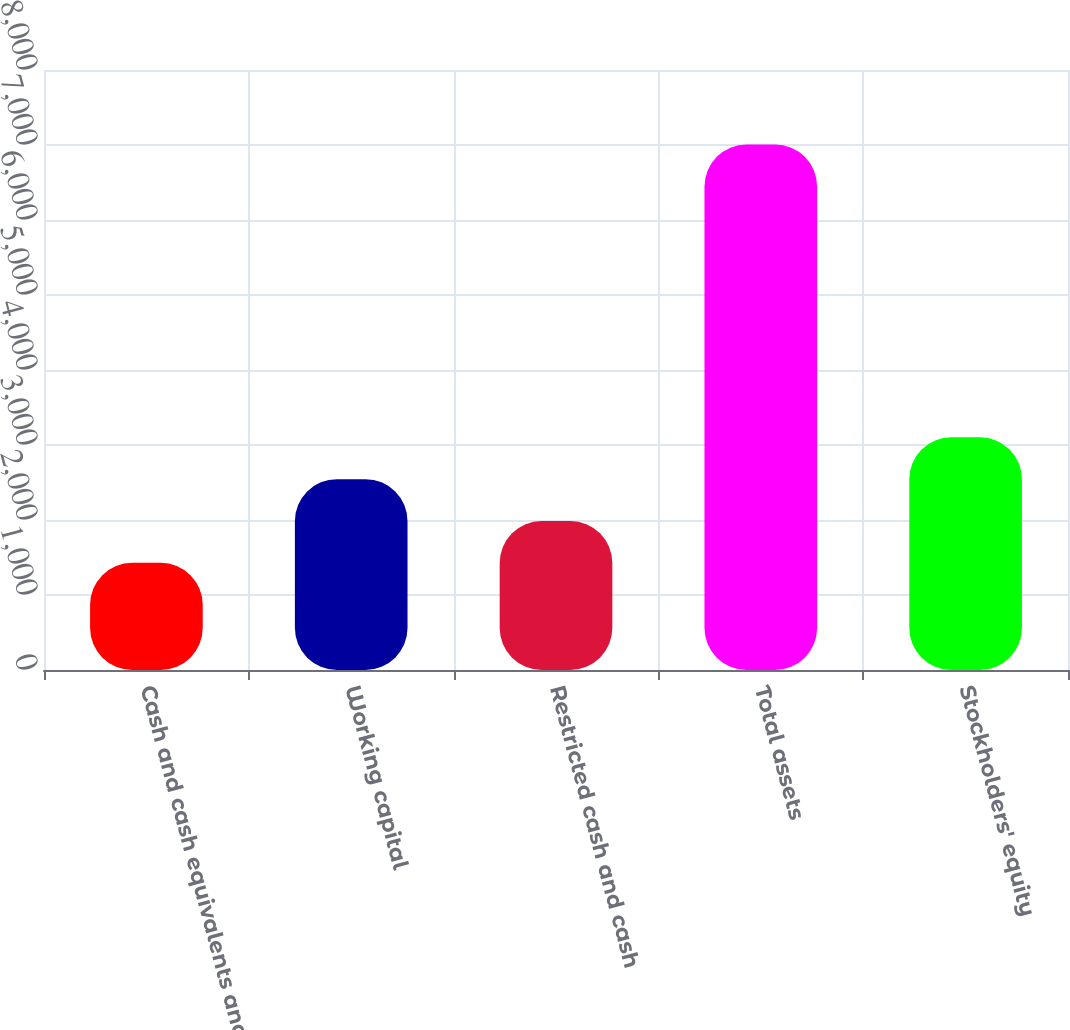Convert chart to OTSL. <chart><loc_0><loc_0><loc_500><loc_500><bar_chart><fcel>Cash and cash equivalents and<fcel>Working capital<fcel>Restricted cash and cash<fcel>Total assets<fcel>Stockholders' equity<nl><fcel>1429<fcel>2544.6<fcel>1986.8<fcel>7007<fcel>3102.4<nl></chart> 